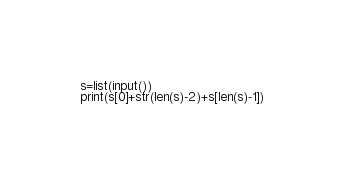Convert code to text. <code><loc_0><loc_0><loc_500><loc_500><_Python_>s=list(input())
print(s[0]+str(len(s)-2)+s[len(s)-1])</code> 